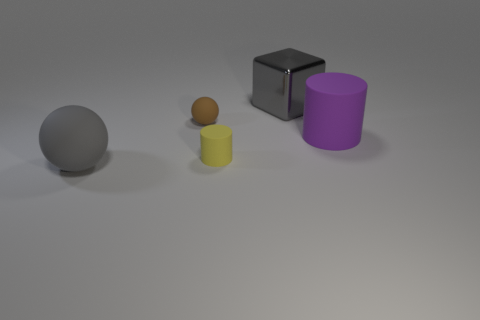Add 3 purple matte cylinders. How many objects exist? 8 Subtract all cylinders. How many objects are left? 3 Add 4 cylinders. How many cylinders are left? 6 Add 2 purple matte objects. How many purple matte objects exist? 3 Subtract 0 blue blocks. How many objects are left? 5 Subtract all big rubber things. Subtract all large metallic cubes. How many objects are left? 2 